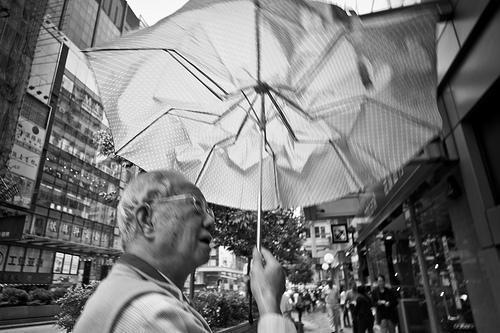How many men are holding an umbrella?
Give a very brief answer. 1. How many hats is the man in the foreground wearing?
Give a very brief answer. 0. 